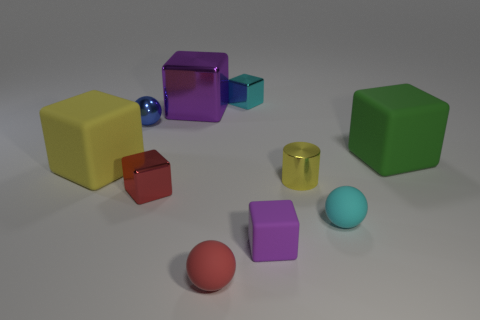Is there any other thing that is the same color as the large metal thing?
Provide a succinct answer. Yes. What number of yellow things are both to the left of the red sphere and to the right of the yellow matte thing?
Offer a terse response. 0. Do the cyan object that is in front of the cyan cube and the cyan cube behind the large green matte cube have the same size?
Provide a succinct answer. Yes. How many things are cubes left of the purple metal object or large objects?
Your answer should be very brief. 4. What is the cyan object behind the red shiny object made of?
Provide a succinct answer. Metal. What is the material of the small cyan cube?
Make the answer very short. Metal. What is the material of the small cyan object behind the tiny ball right of the purple thing in front of the green thing?
Offer a terse response. Metal. Are there any other things that have the same material as the cyan sphere?
Your answer should be compact. Yes. There is a yellow cylinder; is it the same size as the ball left of the large shiny thing?
Your answer should be very brief. Yes. What number of things are tiny blocks that are in front of the small cyan ball or spheres that are in front of the tiny cyan matte object?
Provide a succinct answer. 2. 